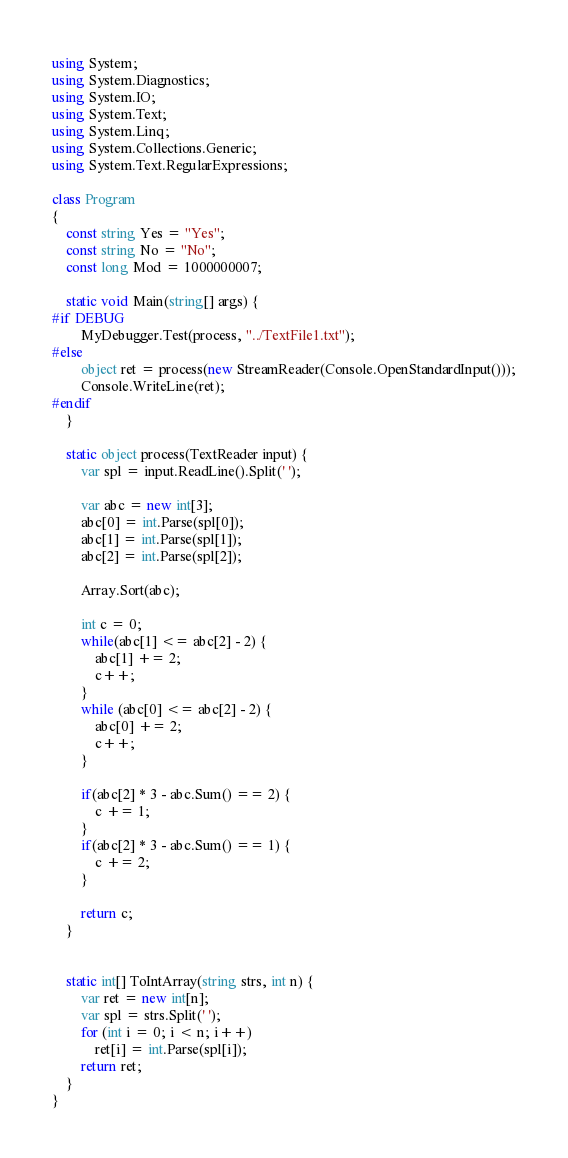<code> <loc_0><loc_0><loc_500><loc_500><_C#_>using System;
using System.Diagnostics;
using System.IO;
using System.Text;
using System.Linq;
using System.Collections.Generic;
using System.Text.RegularExpressions;

class Program
{
    const string Yes = "Yes";
    const string No = "No";
    const long Mod = 1000000007;

    static void Main(string[] args) {
#if DEBUG
        MyDebugger.Test(process, "../TextFile1.txt");
#else
        object ret = process(new StreamReader(Console.OpenStandardInput()));
        Console.WriteLine(ret);
#endif
    }

    static object process(TextReader input) {
        var spl = input.ReadLine().Split(' ');
        
        var abc = new int[3];
        abc[0] = int.Parse(spl[0]);
        abc[1] = int.Parse(spl[1]);
        abc[2] = int.Parse(spl[2]);

        Array.Sort(abc);

        int c = 0;
        while(abc[1] <= abc[2] - 2) {
            abc[1] += 2;
            c++;
        }
        while (abc[0] <= abc[2] - 2) {
            abc[0] += 2;
            c++;
        }

        if(abc[2] * 3 - abc.Sum() == 2) {
            c += 1;
        }
        if(abc[2] * 3 - abc.Sum() == 1) {
            c += 2;
        }

        return c;
    }


    static int[] ToIntArray(string strs, int n) {
        var ret = new int[n];
        var spl = strs.Split(' ');
        for (int i = 0; i < n; i++)
            ret[i] = int.Parse(spl[i]);
        return ret;
    }
}
</code> 